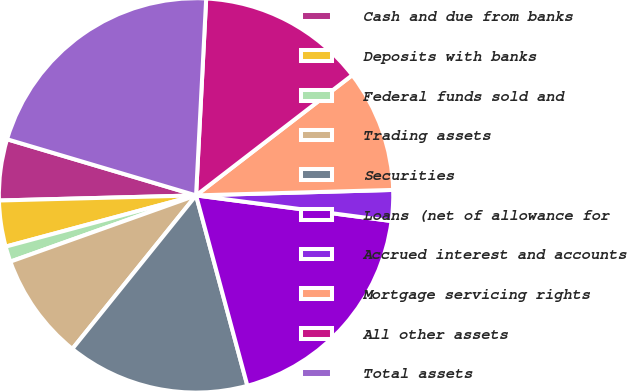Convert chart. <chart><loc_0><loc_0><loc_500><loc_500><pie_chart><fcel>Cash and due from banks<fcel>Deposits with banks<fcel>Federal funds sold and<fcel>Trading assets<fcel>Securities<fcel>Loans (net of allowance for<fcel>Accrued interest and accounts<fcel>Mortgage servicing rights<fcel>All other assets<fcel>Total assets<nl><fcel>5.01%<fcel>3.77%<fcel>1.27%<fcel>8.75%<fcel>14.99%<fcel>18.73%<fcel>2.52%<fcel>10.0%<fcel>13.74%<fcel>21.22%<nl></chart> 